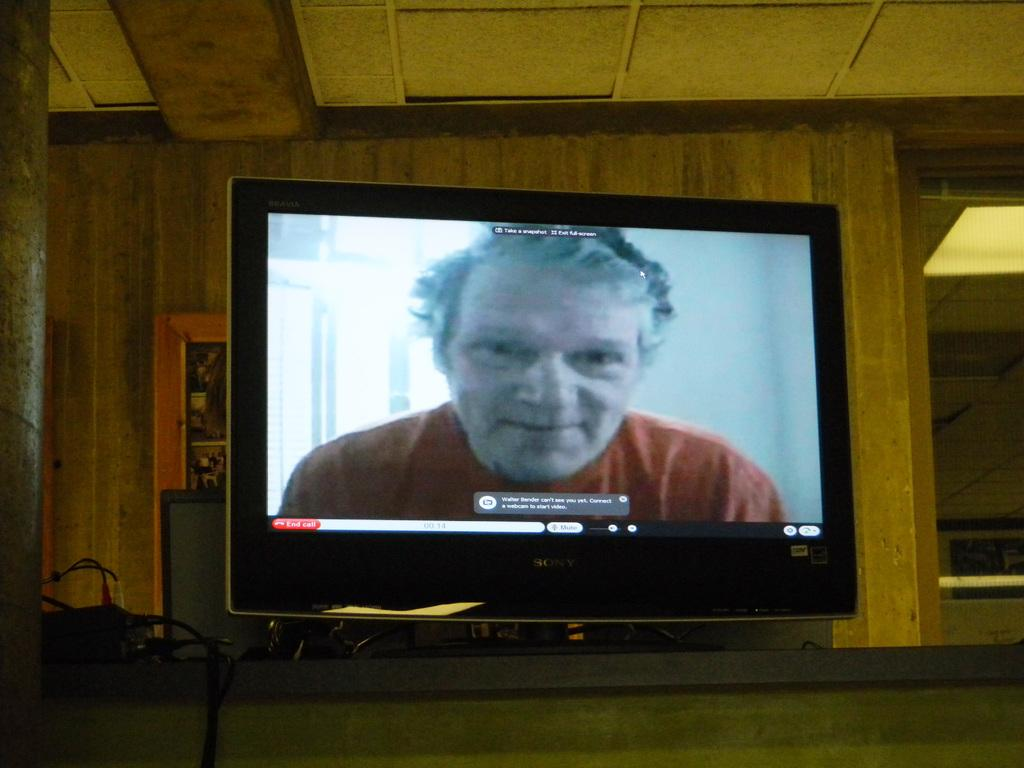<image>
Give a short and clear explanation of the subsequent image. a tv with the word mute at the bottom of it 